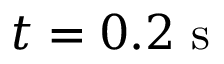<formula> <loc_0><loc_0><loc_500><loc_500>t = 0 . 2 s</formula> 